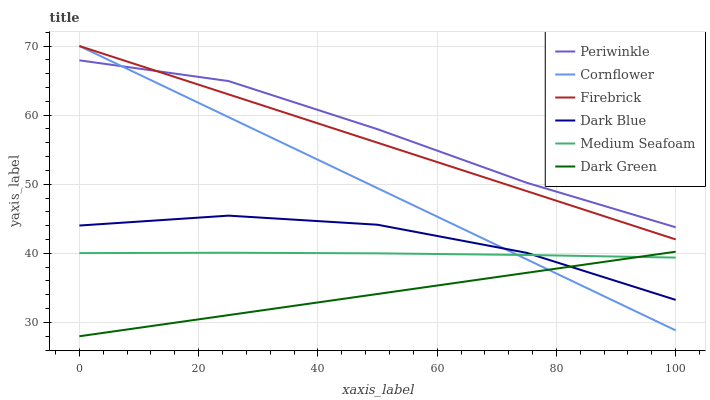Does Dark Green have the minimum area under the curve?
Answer yes or no. Yes. Does Periwinkle have the maximum area under the curve?
Answer yes or no. Yes. Does Firebrick have the minimum area under the curve?
Answer yes or no. No. Does Firebrick have the maximum area under the curve?
Answer yes or no. No. Is Cornflower the smoothest?
Answer yes or no. Yes. Is Dark Blue the roughest?
Answer yes or no. Yes. Is Firebrick the smoothest?
Answer yes or no. No. Is Firebrick the roughest?
Answer yes or no. No. Does Dark Green have the lowest value?
Answer yes or no. Yes. Does Firebrick have the lowest value?
Answer yes or no. No. Does Firebrick have the highest value?
Answer yes or no. Yes. Does Dark Blue have the highest value?
Answer yes or no. No. Is Dark Green less than Firebrick?
Answer yes or no. Yes. Is Periwinkle greater than Medium Seafoam?
Answer yes or no. Yes. Does Cornflower intersect Firebrick?
Answer yes or no. Yes. Is Cornflower less than Firebrick?
Answer yes or no. No. Is Cornflower greater than Firebrick?
Answer yes or no. No. Does Dark Green intersect Firebrick?
Answer yes or no. No. 